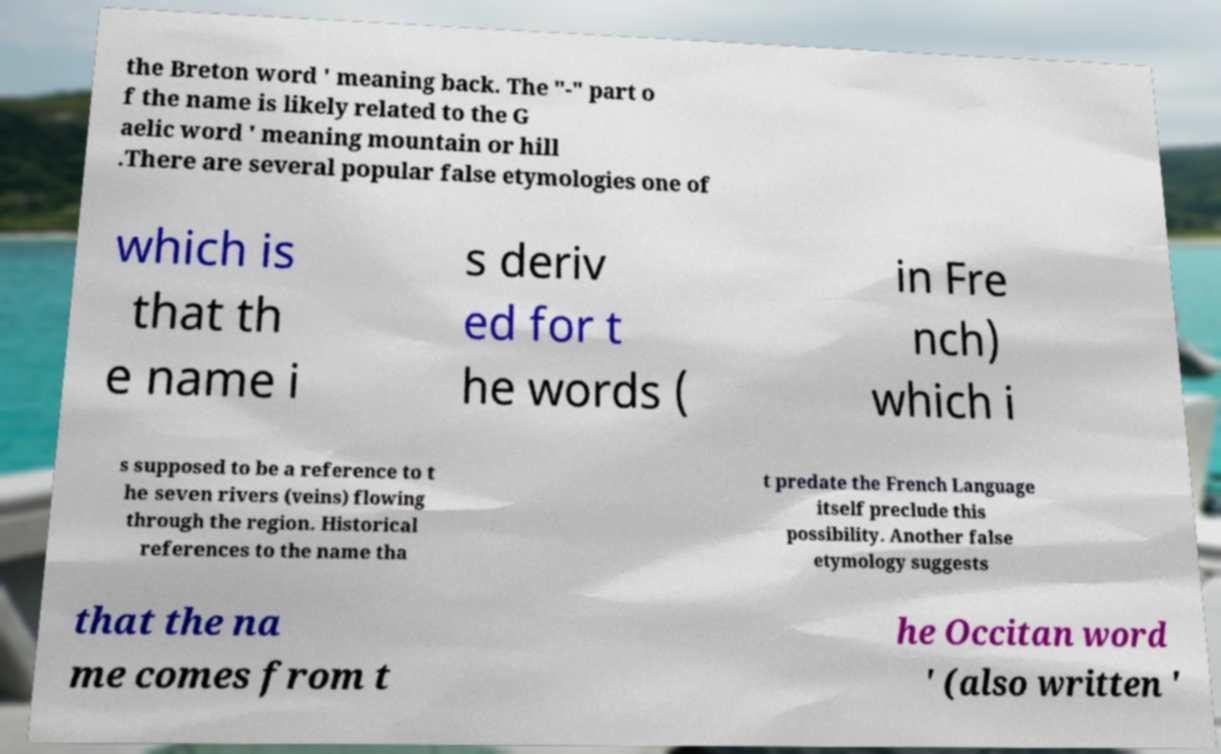I need the written content from this picture converted into text. Can you do that? the Breton word ' meaning back. The "-" part o f the name is likely related to the G aelic word ' meaning mountain or hill .There are several popular false etymologies one of which is that th e name i s deriv ed for t he words ( in Fre nch) which i s supposed to be a reference to t he seven rivers (veins) flowing through the region. Historical references to the name tha t predate the French Language itself preclude this possibility. Another false etymology suggests that the na me comes from t he Occitan word ' (also written ' 